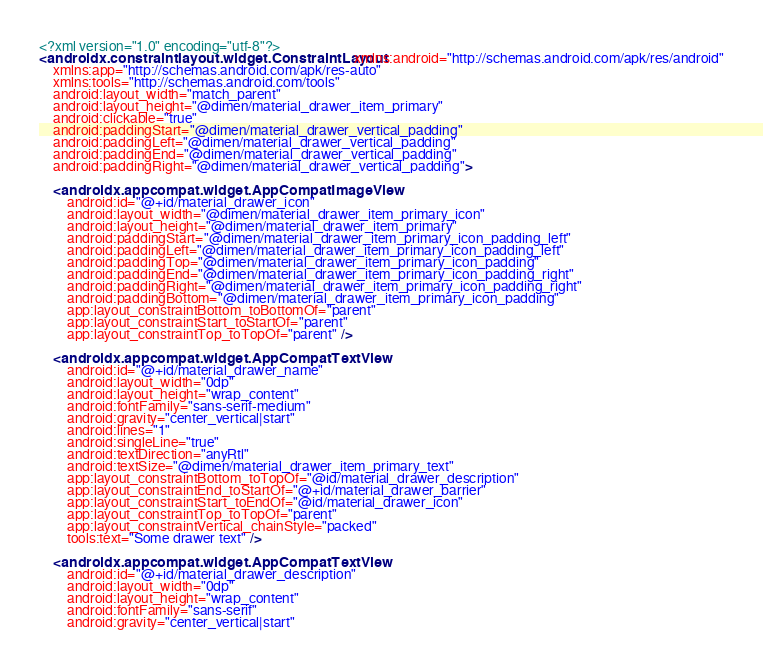<code> <loc_0><loc_0><loc_500><loc_500><_XML_><?xml version="1.0" encoding="utf-8"?>
<androidx.constraintlayout.widget.ConstraintLayout xmlns:android="http://schemas.android.com/apk/res/android"
    xmlns:app="http://schemas.android.com/apk/res-auto"
    xmlns:tools="http://schemas.android.com/tools"
    android:layout_width="match_parent"
    android:layout_height="@dimen/material_drawer_item_primary"
    android:clickable="true"
    android:paddingStart="@dimen/material_drawer_vertical_padding"
    android:paddingLeft="@dimen/material_drawer_vertical_padding"
    android:paddingEnd="@dimen/material_drawer_vertical_padding"
    android:paddingRight="@dimen/material_drawer_vertical_padding">

    <androidx.appcompat.widget.AppCompatImageView
        android:id="@+id/material_drawer_icon"
        android:layout_width="@dimen/material_drawer_item_primary_icon"
        android:layout_height="@dimen/material_drawer_item_primary"
        android:paddingStart="@dimen/material_drawer_item_primary_icon_padding_left"
        android:paddingLeft="@dimen/material_drawer_item_primary_icon_padding_left"
        android:paddingTop="@dimen/material_drawer_item_primary_icon_padding"
        android:paddingEnd="@dimen/material_drawer_item_primary_icon_padding_right"
        android:paddingRight="@dimen/material_drawer_item_primary_icon_padding_right"
        android:paddingBottom="@dimen/material_drawer_item_primary_icon_padding"
        app:layout_constraintBottom_toBottomOf="parent"
        app:layout_constraintStart_toStartOf="parent"
        app:layout_constraintTop_toTopOf="parent" />

    <androidx.appcompat.widget.AppCompatTextView
        android:id="@+id/material_drawer_name"
        android:layout_width="0dp"
        android:layout_height="wrap_content"
        android:fontFamily="sans-serif-medium"
        android:gravity="center_vertical|start"
        android:lines="1"
        android:singleLine="true"
        android:textDirection="anyRtl"
        android:textSize="@dimen/material_drawer_item_primary_text"
        app:layout_constraintBottom_toTopOf="@id/material_drawer_description"
        app:layout_constraintEnd_toStartOf="@+id/material_drawer_barrier"
        app:layout_constraintStart_toEndOf="@id/material_drawer_icon"
        app:layout_constraintTop_toTopOf="parent"
        app:layout_constraintVertical_chainStyle="packed"
        tools:text="Some drawer text" />

    <androidx.appcompat.widget.AppCompatTextView
        android:id="@+id/material_drawer_description"
        android:layout_width="0dp"
        android:layout_height="wrap_content"
        android:fontFamily="sans-serif"
        android:gravity="center_vertical|start"</code> 